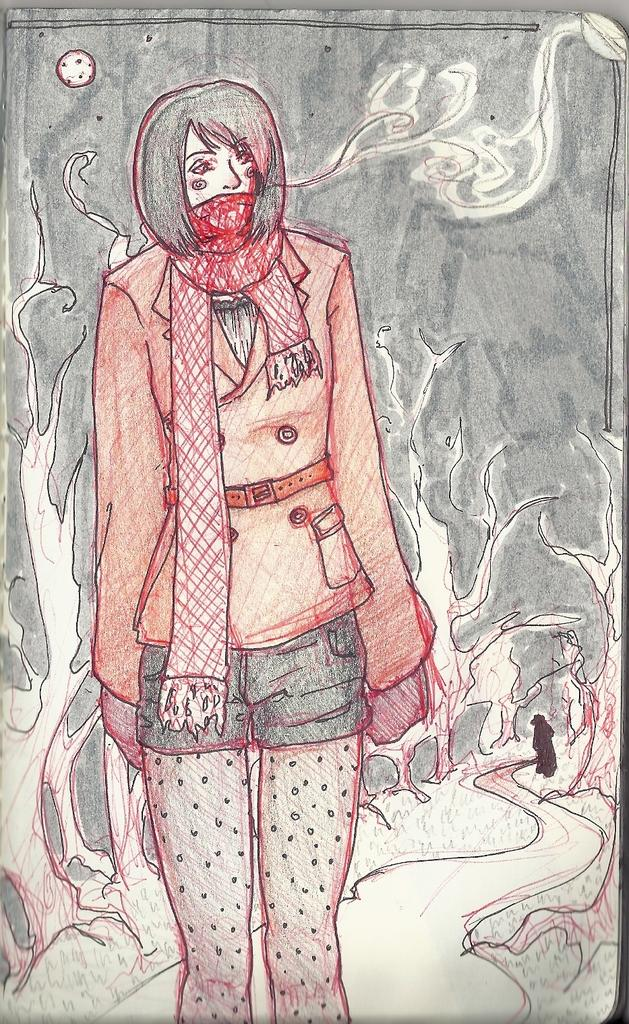What is depicted in the image? There is a drawing of a woman in the image. How is the woman positioned in the drawing? The woman is standing. What is the woman wearing on her face in the drawing? The woman is wearing a scarf on her face. Can you describe the other person visible in the image? There is another person visible in the image, but they are far behind the woman. What type of advertisement can be seen in the alley behind the woman? There is no alley or advertisement present in the image; it is a drawing of a woman with a scarf on her face and another person far behind her. 